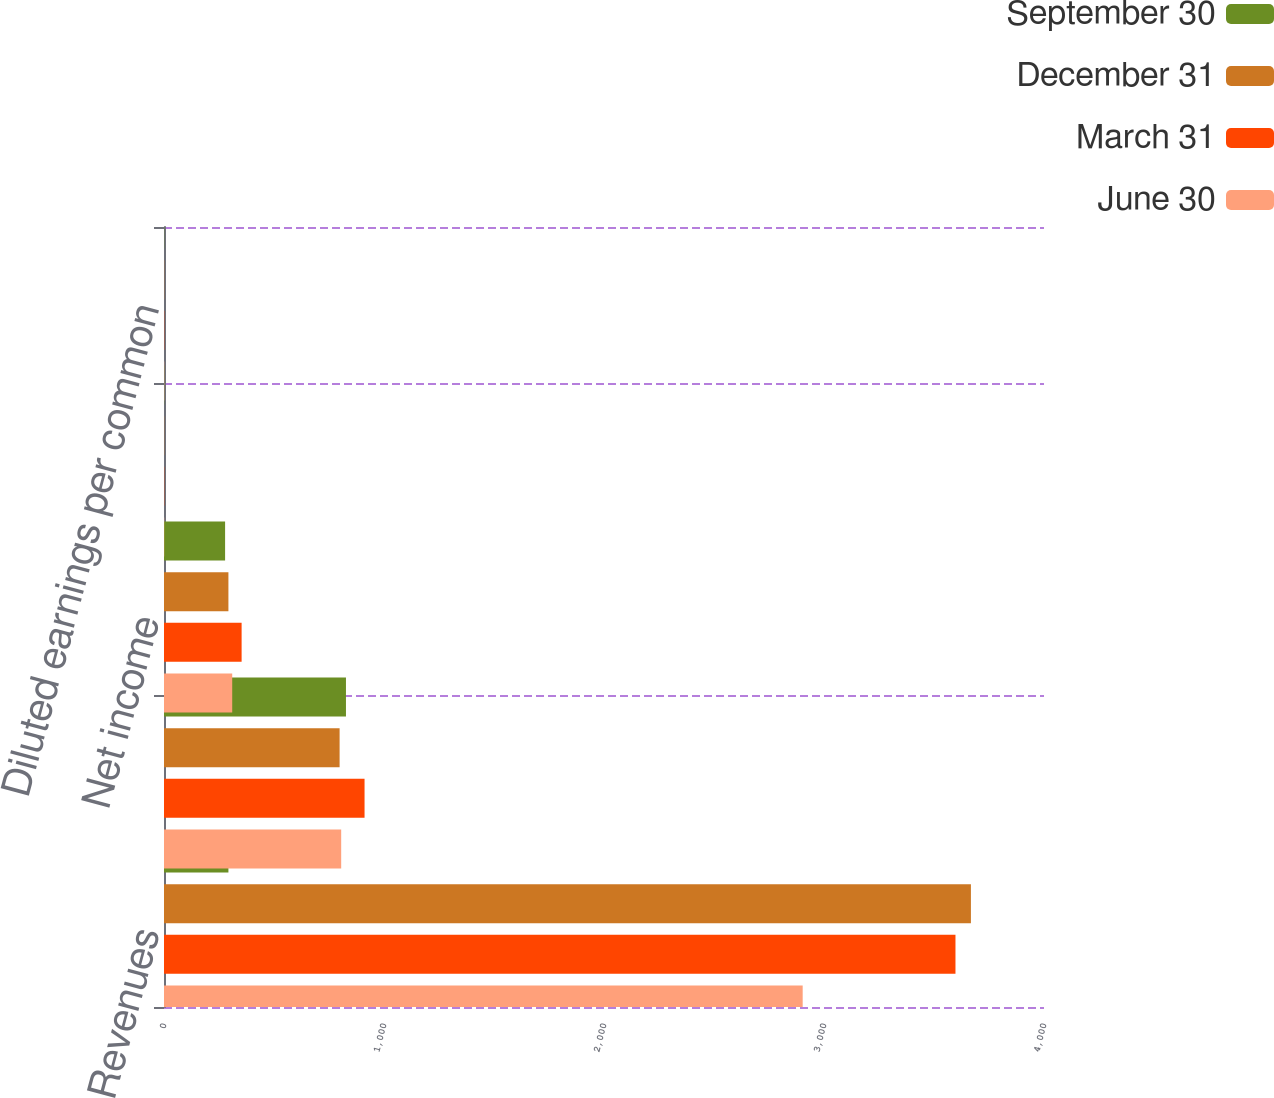Convert chart to OTSL. <chart><loc_0><loc_0><loc_500><loc_500><stacked_bar_chart><ecel><fcel>Revenues<fcel>Gross profit<fcel>Net income<fcel>Basic earnings per common<fcel>Diluted earnings per common<nl><fcel>September 30<fcel>292.8<fcel>827.1<fcel>277.7<fcel>0.89<fcel>0.88<nl><fcel>December 31<fcel>3667.8<fcel>798.2<fcel>292.8<fcel>0.94<fcel>0.93<nl><fcel>March 31<fcel>3597.6<fcel>911.6<fcel>352.8<fcel>1.13<fcel>1.11<nl><fcel>June 30<fcel>2903.1<fcel>805.4<fcel>310.1<fcel>0.99<fcel>0.98<nl></chart> 